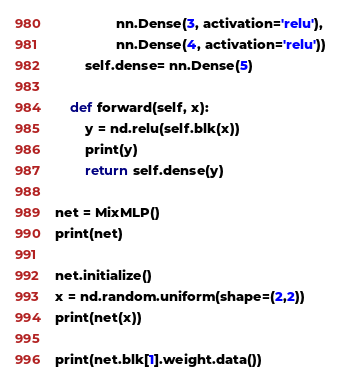<code> <loc_0><loc_0><loc_500><loc_500><_Python_>                nn.Dense(3, activation='relu'),
                nn.Dense(4, activation='relu'))
        self.dense= nn.Dense(5)

    def forward(self, x):
        y = nd.relu(self.blk(x))
        print(y)
        return self.dense(y)

net = MixMLP()
print(net)

net.initialize()
x = nd.random.uniform(shape=(2,2))
print(net(x))

print(net.blk[1].weight.data())
</code> 